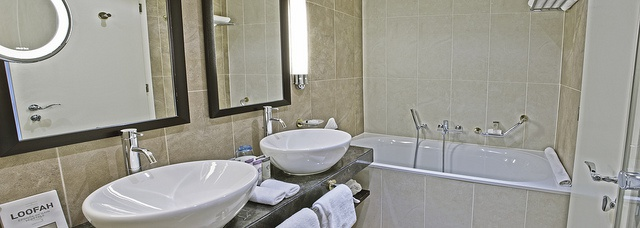Describe the objects in this image and their specific colors. I can see sink in darkgray, lightgray, and gray tones, sink in darkgray, lightgray, and gray tones, and book in darkgray, lightgray, and gray tones in this image. 